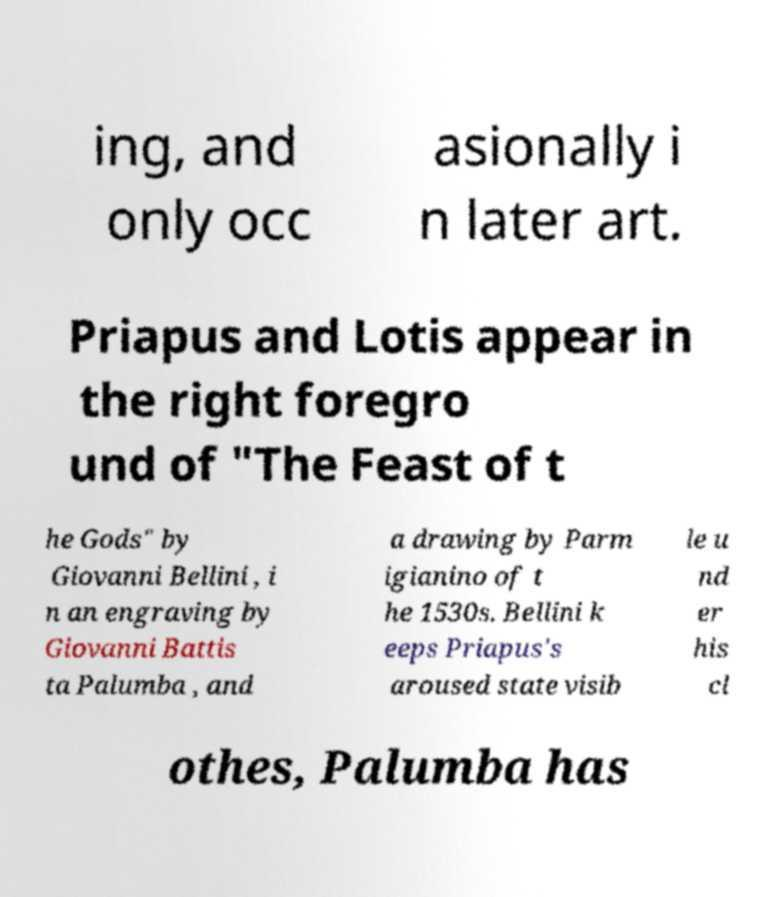Can you read and provide the text displayed in the image?This photo seems to have some interesting text. Can you extract and type it out for me? ing, and only occ asionally i n later art. Priapus and Lotis appear in the right foregro und of "The Feast of t he Gods" by Giovanni Bellini , i n an engraving by Giovanni Battis ta Palumba , and a drawing by Parm igianino of t he 1530s. Bellini k eeps Priapus's aroused state visib le u nd er his cl othes, Palumba has 